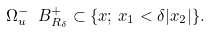<formula> <loc_0><loc_0><loc_500><loc_500>\Omega _ { u } ^ { - } \ B ^ { + } _ { R _ { \delta } } \subset \{ x ; \, x _ { 1 } < \delta | x _ { 2 } | \} .</formula> 